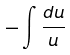Convert formula to latex. <formula><loc_0><loc_0><loc_500><loc_500>- \int \frac { d u } { u }</formula> 